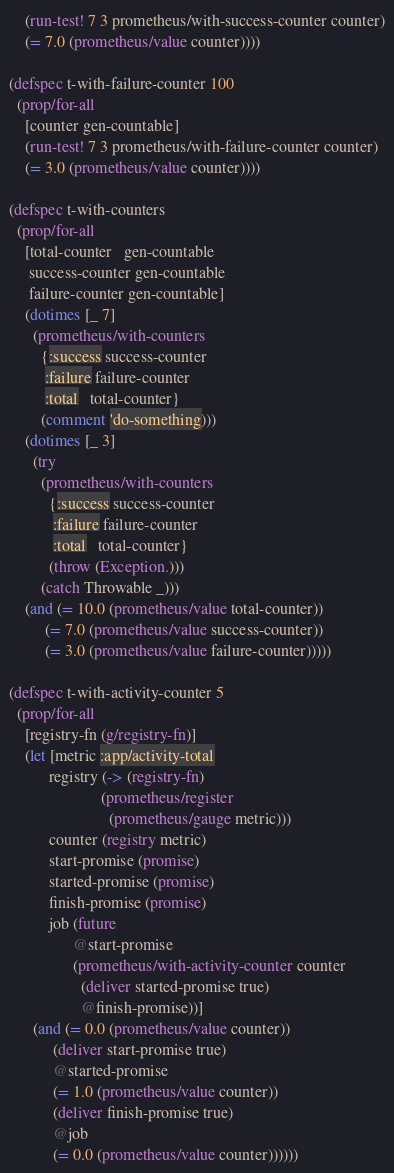Convert code to text. <code><loc_0><loc_0><loc_500><loc_500><_Clojure_>    (run-test! 7 3 prometheus/with-success-counter counter)
    (= 7.0 (prometheus/value counter))))

(defspec t-with-failure-counter 100
  (prop/for-all
    [counter gen-countable]
    (run-test! 7 3 prometheus/with-failure-counter counter)
    (= 3.0 (prometheus/value counter))))

(defspec t-with-counters
  (prop/for-all
    [total-counter   gen-countable
     success-counter gen-countable
     failure-counter gen-countable]
    (dotimes [_ 7]
      (prometheus/with-counters
        {:success success-counter
         :failure failure-counter
         :total   total-counter}
        (comment 'do-something)))
    (dotimes [_ 3]
      (try
        (prometheus/with-counters
          {:success success-counter
           :failure failure-counter
           :total   total-counter}
          (throw (Exception.)))
        (catch Throwable _)))
    (and (= 10.0 (prometheus/value total-counter))
         (= 7.0 (prometheus/value success-counter))
         (= 3.0 (prometheus/value failure-counter)))))

(defspec t-with-activity-counter 5
  (prop/for-all
    [registry-fn (g/registry-fn)]
    (let [metric :app/activity-total
          registry (-> (registry-fn)
                       (prometheus/register
                         (prometheus/gauge metric)))
          counter (registry metric)
          start-promise (promise)
          started-promise (promise)
          finish-promise (promise)
          job (future
                @start-promise
                (prometheus/with-activity-counter counter
                  (deliver started-promise true)
                  @finish-promise))]
      (and (= 0.0 (prometheus/value counter))
           (deliver start-promise true)
           @started-promise
           (= 1.0 (prometheus/value counter))
           (deliver finish-promise true)
           @job
           (= 0.0 (prometheus/value counter))))))
</code> 